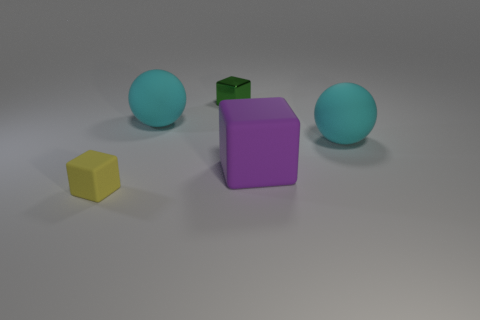Add 4 big cyan rubber things. How many objects exist? 9 Subtract all yellow rubber cubes. How many cubes are left? 2 Subtract all cubes. How many objects are left? 2 Subtract 1 balls. How many balls are left? 1 Add 4 tiny brown metallic balls. How many tiny brown metallic balls exist? 4 Subtract all yellow blocks. How many blocks are left? 2 Subtract 0 cyan cylinders. How many objects are left? 5 Subtract all purple blocks. Subtract all purple cylinders. How many blocks are left? 2 Subtract all small yellow shiny cubes. Subtract all large matte objects. How many objects are left? 2 Add 5 large cubes. How many large cubes are left? 6 